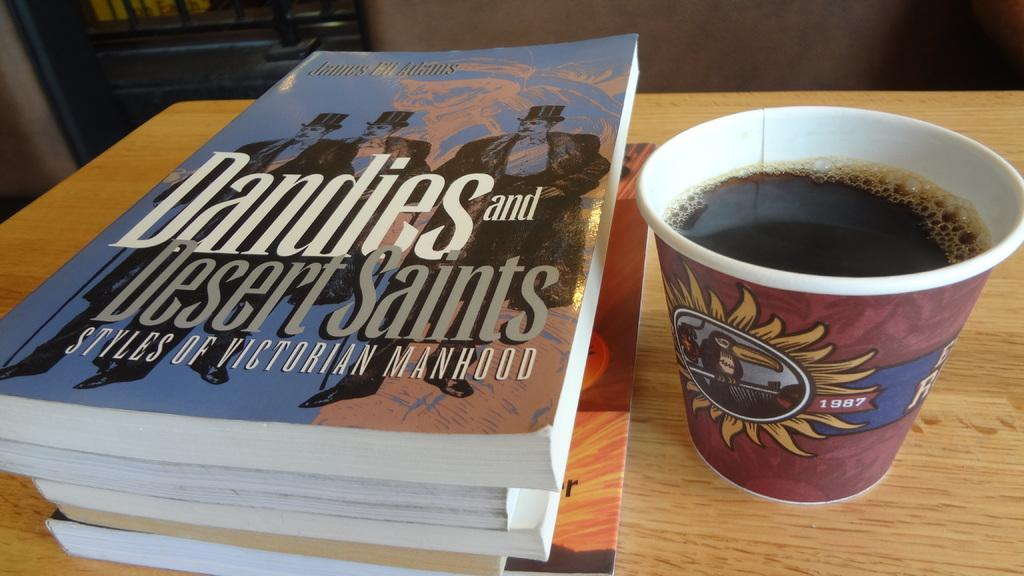<image>
Provide a brief description of the given image. Cup of coffee next to a book named "Dandies and Desert Saints". 